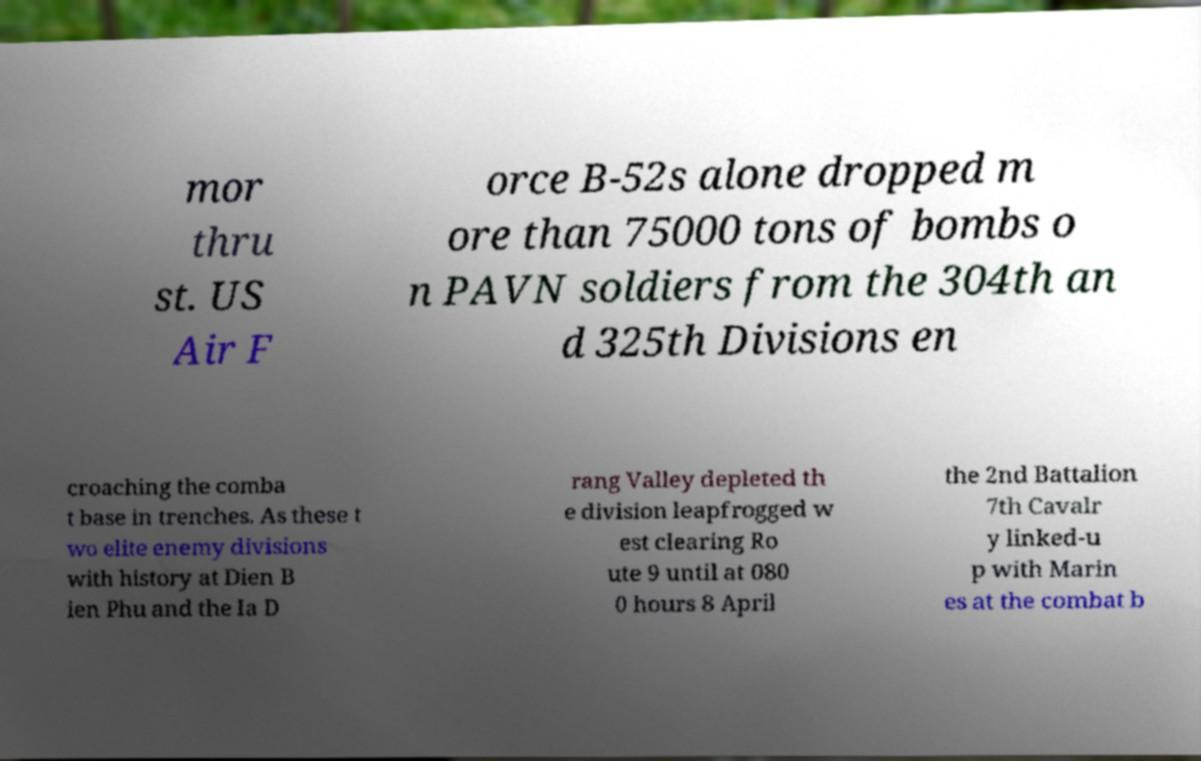Can you read and provide the text displayed in the image?This photo seems to have some interesting text. Can you extract and type it out for me? mor thru st. US Air F orce B-52s alone dropped m ore than 75000 tons of bombs o n PAVN soldiers from the 304th an d 325th Divisions en croaching the comba t base in trenches. As these t wo elite enemy divisions with history at Dien B ien Phu and the Ia D rang Valley depleted th e division leapfrogged w est clearing Ro ute 9 until at 080 0 hours 8 April the 2nd Battalion 7th Cavalr y linked-u p with Marin es at the combat b 